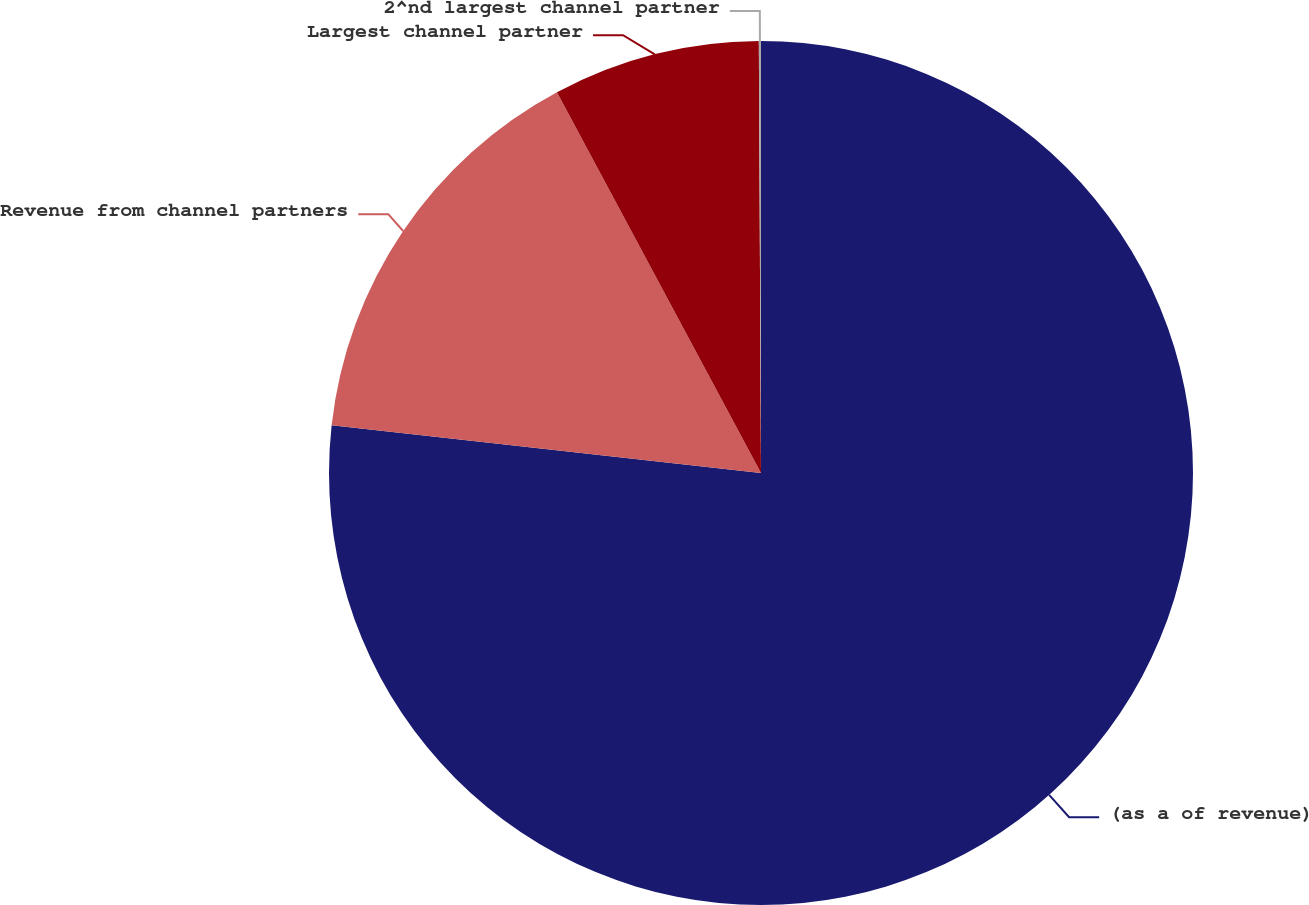Convert chart. <chart><loc_0><loc_0><loc_500><loc_500><pie_chart><fcel>(as a of revenue)<fcel>Revenue from channel partners<fcel>Largest channel partner<fcel>2^nd largest channel partner<nl><fcel>76.76%<fcel>15.41%<fcel>7.75%<fcel>0.08%<nl></chart> 